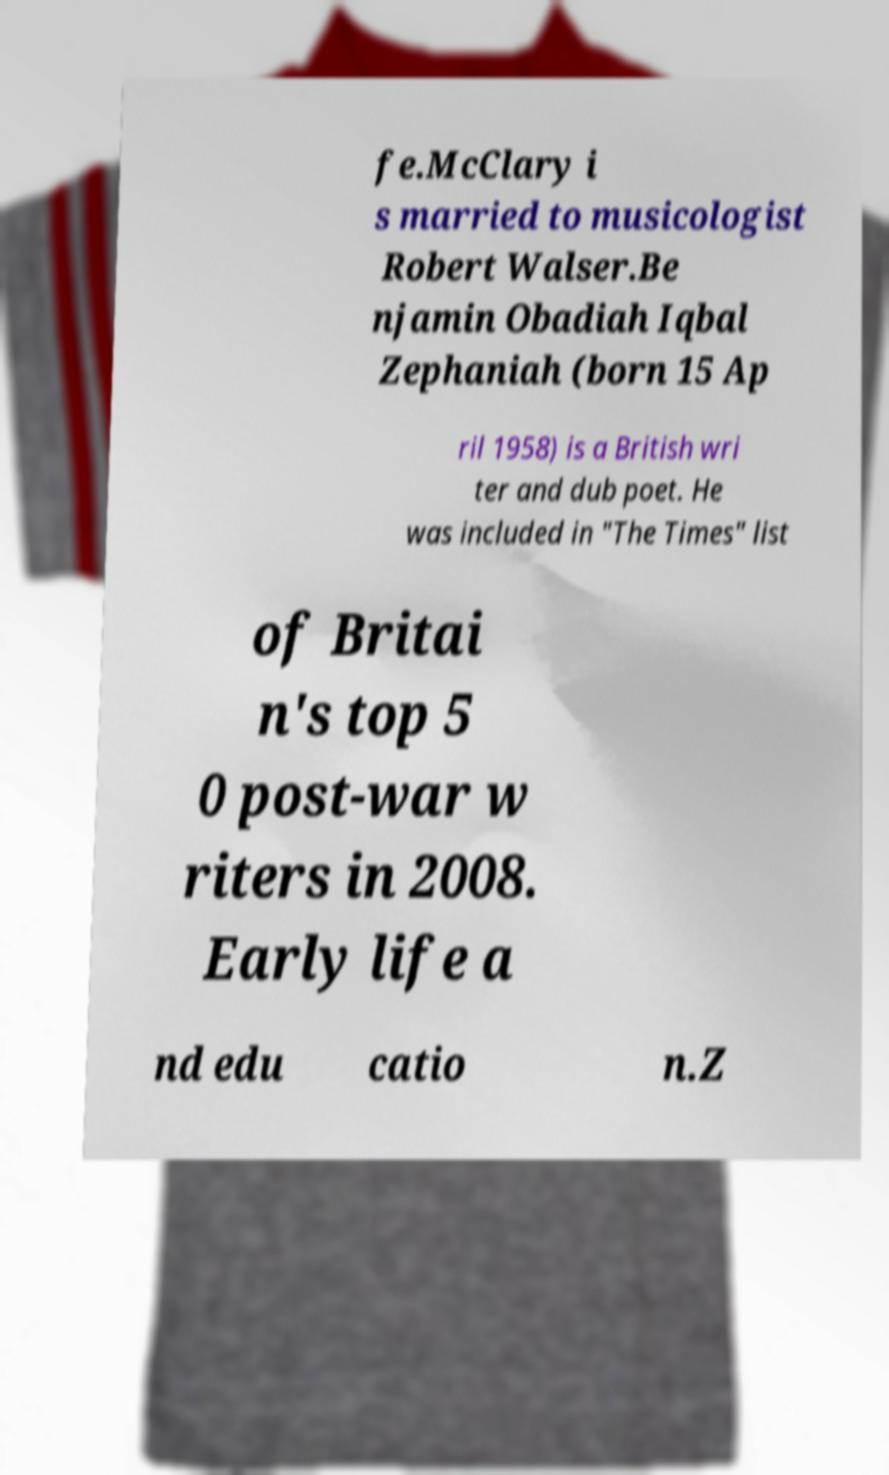Could you extract and type out the text from this image? fe.McClary i s married to musicologist Robert Walser.Be njamin Obadiah Iqbal Zephaniah (born 15 Ap ril 1958) is a British wri ter and dub poet. He was included in "The Times" list of Britai n's top 5 0 post-war w riters in 2008. Early life a nd edu catio n.Z 